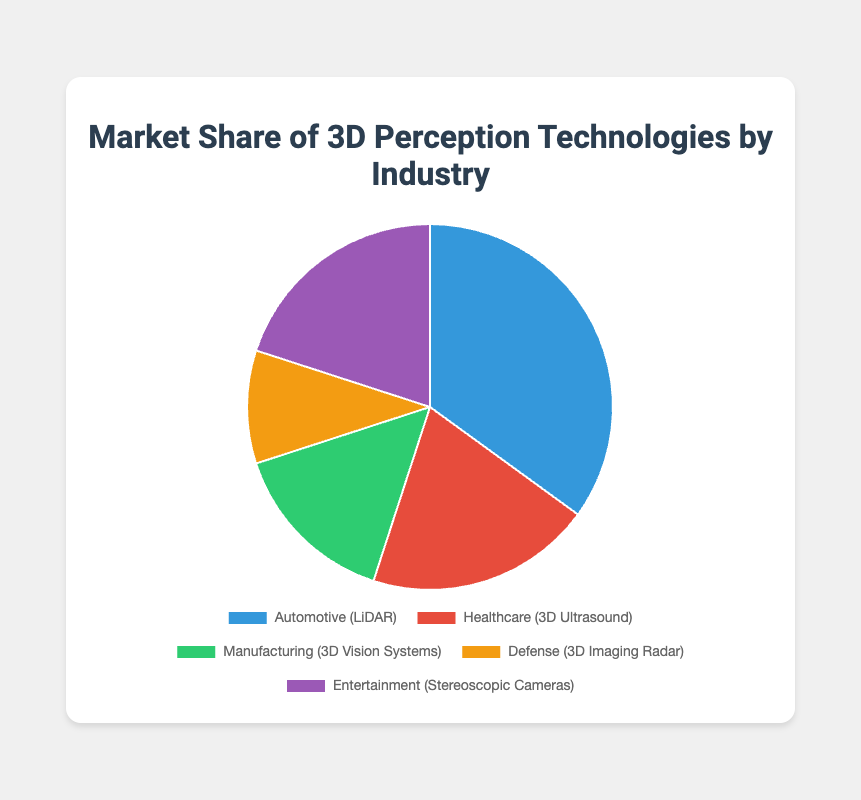Which industry has the highest market share in 3D perception technologies? The slice in the pie chart representing "Automotive (LiDAR)" is the largest, indicating it has the highest market share compared to other industries.
Answer: Automotive How much larger is the market share of Automotive compared to Defense? The market share of Automotive is 35% and Defense is 10%. The difference is 35% - 10% = 25%.
Answer: 25% What is the combined market share of Healthcare and Entertainment industries? Healthcare and Entertainment each have a market share of 20%. Thus, combined market share is 20% + 20% = 40%.
Answer: 40% Which industry has the smallest market share, and what is it? The slice representing "Defense (3D Imaging Radar)" is the smallest, indicating it has the smallest market share of 10%.
Answer: Defense, 10% How does the market share of Manufacturing compare to Entertainment? Manufacturing has a market share of 15% and Entertainment has 20%. Since 15% < 20%, Manufacturing's share is smaller.
Answer: Manufacturing has a smaller share What is the average market share of the five industries? Sum the market shares: 35% (Automotive) + 20% (Healthcare) + 15% (Manufacturing) + 10% (Defense) + 20% (Entertainment) = 100%. The average is 100% / 5 = 20%.
Answer: 20% If Healthcare's market share increased by 5%, what would be the new total market share for Healthcare and Manufacturing? If Healthcare increased by 5%, its share would be 20% + 5% = 25%. Adding Manufacturing's 15% gives 25% + 15% = 40%.
Answer: 40% Which two industries have an equal market share, and what is their share? Healthcare (3D Ultrasound) and Entertainment (Stereoscopic Cameras) both have a market share of 20%.
Answer: Healthcare and Entertainment, 20% What is the ratio of the market share between Automotive and Manufacturing industries? Automotive has a market share of 35% and Manufacturing has 15%. The ratio is 35:15 or simplified to 7:3.
Answer: 7:3 What percentage of the market is held by the non-Automotive industries? The total market share for non-Automotive industries is 100% - 35% = 65%.
Answer: 65% 